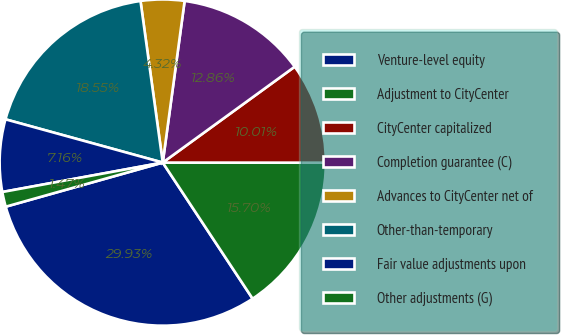Convert chart. <chart><loc_0><loc_0><loc_500><loc_500><pie_chart><fcel>Venture-level equity<fcel>Adjustment to CityCenter<fcel>CityCenter capitalized<fcel>Completion guarantee (C)<fcel>Advances to CityCenter net of<fcel>Other-than-temporary<fcel>Fair value adjustments upon<fcel>Other adjustments (G)<nl><fcel>29.93%<fcel>15.7%<fcel>10.01%<fcel>12.86%<fcel>4.32%<fcel>18.55%<fcel>7.16%<fcel>1.47%<nl></chart> 